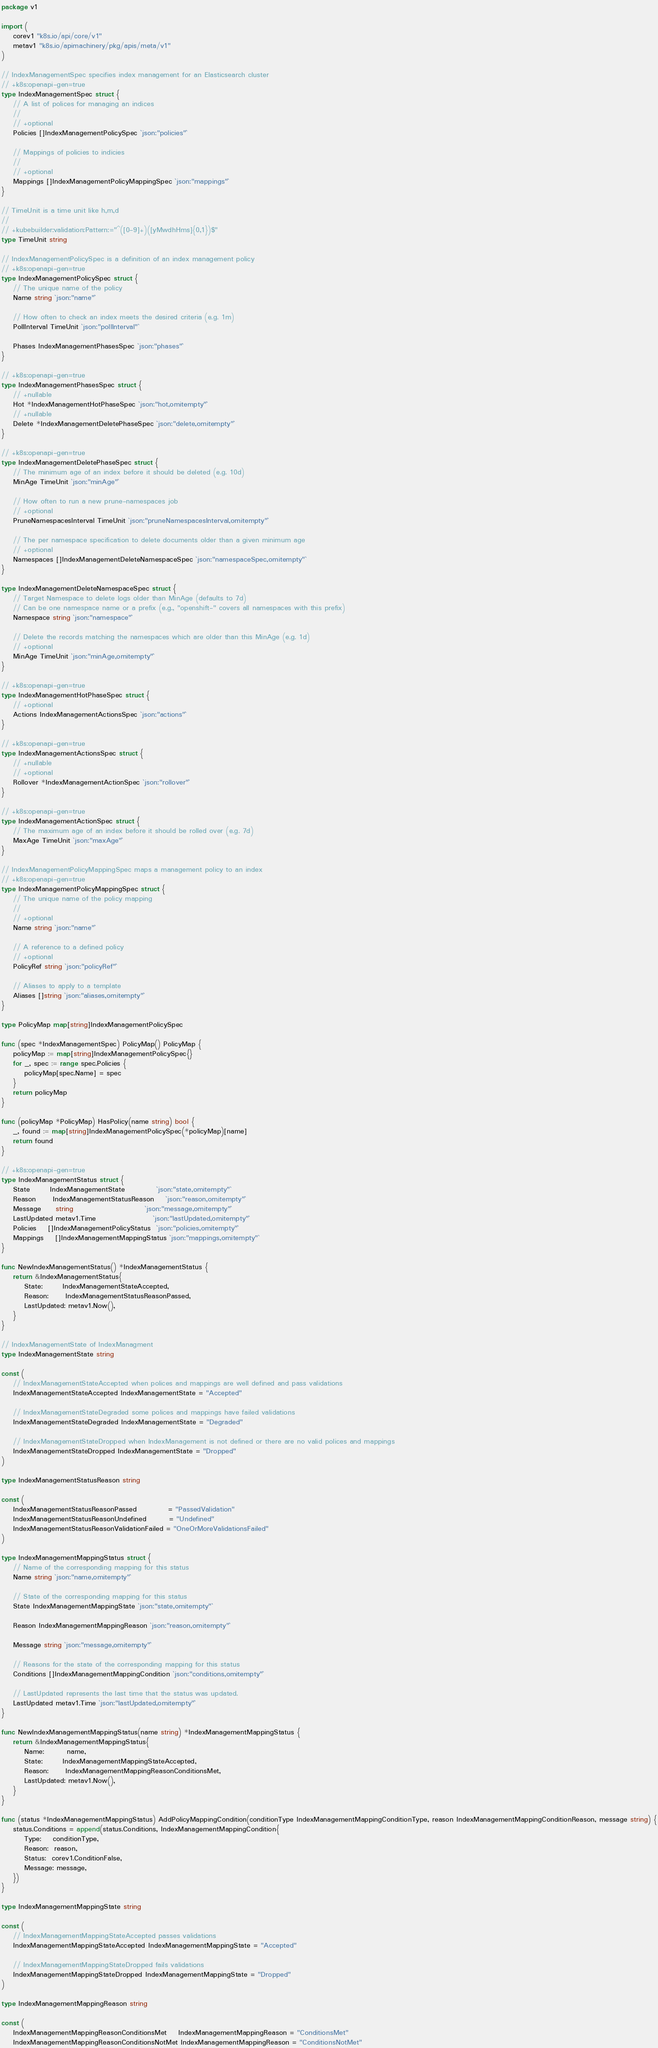<code> <loc_0><loc_0><loc_500><loc_500><_Go_>package v1

import (
	corev1 "k8s.io/api/core/v1"
	metav1 "k8s.io/apimachinery/pkg/apis/meta/v1"
)

// IndexManagementSpec specifies index management for an Elasticsearch cluster
// +k8s:openapi-gen=true
type IndexManagementSpec struct {
	// A list of polices for managing an indices
	//
	// +optional
	Policies []IndexManagementPolicySpec `json:"policies"`

	// Mappings of policies to indicies
	//
	// +optional
	Mappings []IndexManagementPolicyMappingSpec `json:"mappings"`
}

// TimeUnit is a time unit like h,m,d
//
// +kubebuilder:validation:Pattern:="^([0-9]+)([yMwdhHms]{0,1})$"
type TimeUnit string

// IndexManagementPolicySpec is a definition of an index management policy
// +k8s:openapi-gen=true
type IndexManagementPolicySpec struct {
	// The unique name of the policy
	Name string `json:"name"`

	// How often to check an index meets the desired criteria (e.g. 1m)
	PollInterval TimeUnit `json:"pollInterval"`

	Phases IndexManagementPhasesSpec `json:"phases"`
}

// +k8s:openapi-gen=true
type IndexManagementPhasesSpec struct {
	// +nullable
	Hot *IndexManagementHotPhaseSpec `json:"hot,omitempty"`
	// +nullable
	Delete *IndexManagementDeletePhaseSpec `json:"delete,omitempty"`
}

// +k8s:openapi-gen=true
type IndexManagementDeletePhaseSpec struct {
	// The minimum age of an index before it should be deleted (e.g. 10d)
	MinAge TimeUnit `json:"minAge"`

	// How often to run a new prune-namespaces job
	// +optional
	PruneNamespacesInterval TimeUnit `json:"pruneNamespacesInterval,omitempty"`

	// The per namespace specification to delete documents older than a given minimum age
	// +optional
	Namespaces []IndexManagementDeleteNamespaceSpec `json:"namespaceSpec,omitempty"`
}

type IndexManagementDeleteNamespaceSpec struct {
	// Target Namespace to delete logs older than MinAge (defaults to 7d)
	// Can be one namespace name or a prefix (e.g., "openshift-" covers all namespaces with this prefix)
	Namespace string `json:"namespace"`

	// Delete the records matching the namespaces which are older than this MinAge (e.g. 1d)
	// +optional
	MinAge TimeUnit `json:"minAge,omitempty"`
}

// +k8s:openapi-gen=true
type IndexManagementHotPhaseSpec struct {
	// +optional
	Actions IndexManagementActionsSpec `json:"actions"`
}

// +k8s:openapi-gen=true
type IndexManagementActionsSpec struct {
	// +nullable
	// +optional
	Rollover *IndexManagementActionSpec `json:"rollover"`
}

// +k8s:openapi-gen=true
type IndexManagementActionSpec struct {
	// The maximum age of an index before it should be rolled over (e.g. 7d)
	MaxAge TimeUnit `json:"maxAge"`
}

// IndexManagementPolicyMappingSpec maps a management policy to an index
// +k8s:openapi-gen=true
type IndexManagementPolicyMappingSpec struct {
	// The unique name of the policy mapping
	//
	// +optional
	Name string `json:"name"`

	// A reference to a defined policy
	// +optional
	PolicyRef string `json:"policyRef"`

	// Aliases to apply to a template
	Aliases []string `json:"aliases,omitempty"`
}

type PolicyMap map[string]IndexManagementPolicySpec

func (spec *IndexManagementSpec) PolicyMap() PolicyMap {
	policyMap := map[string]IndexManagementPolicySpec{}
	for _, spec := range spec.Policies {
		policyMap[spec.Name] = spec
	}
	return policyMap
}

func (policyMap *PolicyMap) HasPolicy(name string) bool {
	_, found := map[string]IndexManagementPolicySpec(*policyMap)[name]
	return found
}

// +k8s:openapi-gen=true
type IndexManagementStatus struct {
	State       IndexManagementState           `json:"state,omitempty"`
	Reason      IndexManagementStatusReason    `json:"reason,omitempty"`
	Message     string                         `json:"message,omitempty"`
	LastUpdated metav1.Time                    `json:"lastUpdated,omitempty"`
	Policies    []IndexManagementPolicyStatus  `json:"policies,omitempty"`
	Mappings    []IndexManagementMappingStatus `json:"mappings,omitempty"`
}

func NewIndexManagementStatus() *IndexManagementStatus {
	return &IndexManagementStatus{
		State:       IndexManagementStateAccepted,
		Reason:      IndexManagementStatusReasonPassed,
		LastUpdated: metav1.Now(),
	}
}

// IndexManagementState of IndexManagment
type IndexManagementState string

const (
	// IndexManagementStateAccepted when polices and mappings are well defined and pass validations
	IndexManagementStateAccepted IndexManagementState = "Accepted"

	// IndexManagementStateDegraded some polices and mappings have failed validations
	IndexManagementStateDegraded IndexManagementState = "Degraded"

	// IndexManagementStateDropped when IndexManagement is not defined or there are no valid polices and mappings
	IndexManagementStateDropped IndexManagementState = "Dropped"
)

type IndexManagementStatusReason string

const (
	IndexManagementStatusReasonPassed           = "PassedValidation"
	IndexManagementStatusReasonUndefined        = "Undefined"
	IndexManagementStatusReasonValidationFailed = "OneOrMoreValidationsFailed"
)

type IndexManagementMappingStatus struct {
	// Name of the corresponding mapping for this status
	Name string `json:"name,omitempty"`

	// State of the corresponding mapping for this status
	State IndexManagementMappingState `json:"state,omitempty"`

	Reason IndexManagementMappingReason `json:"reason,omitempty"`

	Message string `json:"message,omitempty"`

	// Reasons for the state of the corresponding mapping for this status
	Conditions []IndexManagementMappingCondition `json:"conditions,omitempty"`

	// LastUpdated represents the last time that the status was updated.
	LastUpdated metav1.Time `json:"lastUpdated,omitempty"`
}

func NewIndexManagementMappingStatus(name string) *IndexManagementMappingStatus {
	return &IndexManagementMappingStatus{
		Name:        name,
		State:       IndexManagementMappingStateAccepted,
		Reason:      IndexManagementMappingReasonConditionsMet,
		LastUpdated: metav1.Now(),
	}
}

func (status *IndexManagementMappingStatus) AddPolicyMappingCondition(conditionType IndexManagementMappingConditionType, reason IndexManagementMappingConditionReason, message string) {
	status.Conditions = append(status.Conditions, IndexManagementMappingCondition{
		Type:    conditionType,
		Reason:  reason,
		Status:  corev1.ConditionFalse,
		Message: message,
	})
}

type IndexManagementMappingState string

const (
	// IndexManagementMappingStateAccepted passes validations
	IndexManagementMappingStateAccepted IndexManagementMappingState = "Accepted"

	// IndexManagementMappingStateDropped fails validations
	IndexManagementMappingStateDropped IndexManagementMappingState = "Dropped"
)

type IndexManagementMappingReason string

const (
	IndexManagementMappingReasonConditionsMet    IndexManagementMappingReason = "ConditionsMet"
	IndexManagementMappingReasonConditionsNotMet IndexManagementMappingReason = "ConditionsNotMet"</code> 